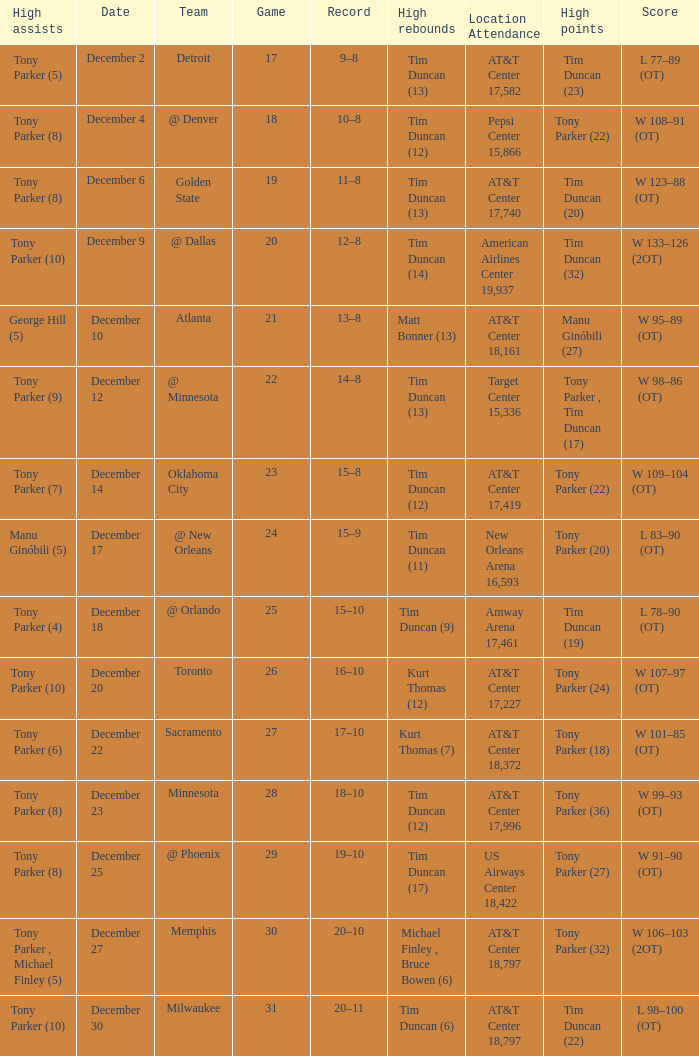What score has tim duncan (14) as the high rebounds? W 133–126 (2OT). 